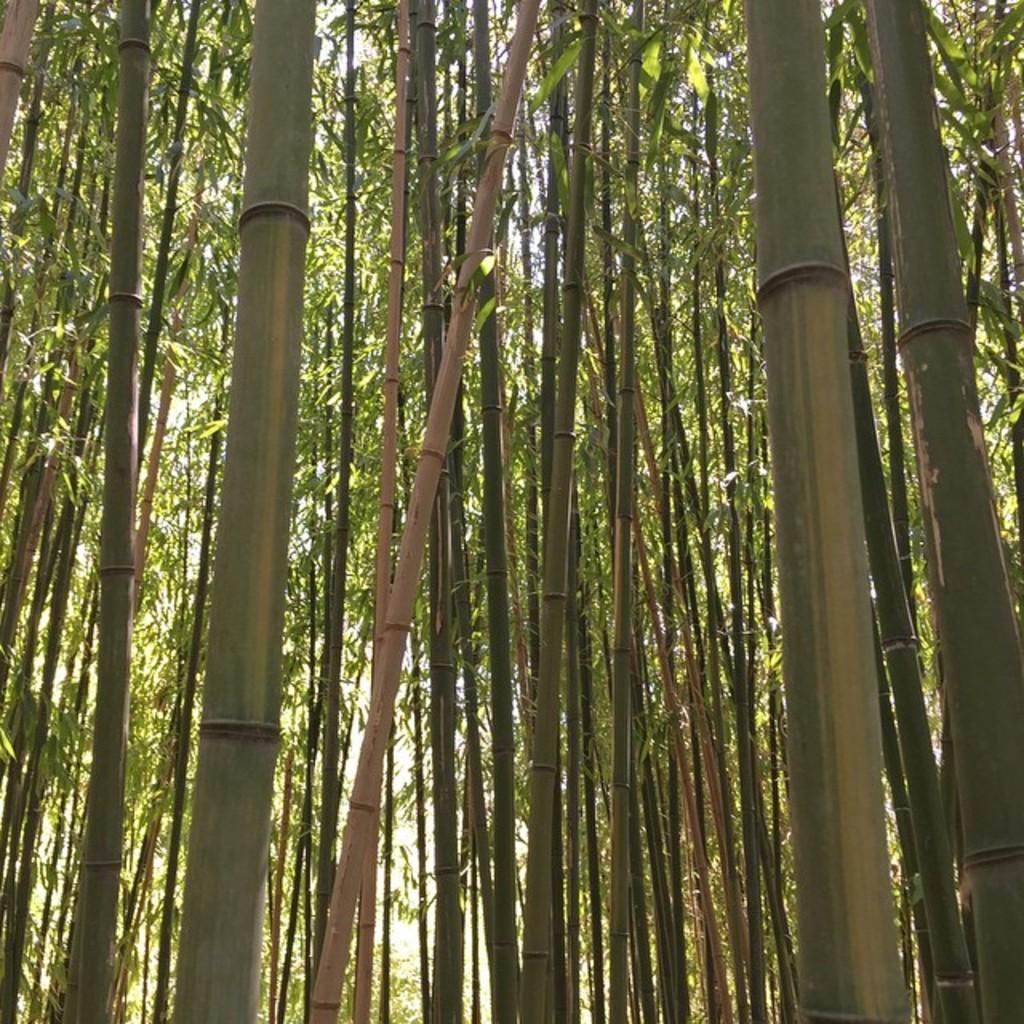Could you give a brief overview of what you see in this image? In this picture I can observe some trees. In the background there is sky. 